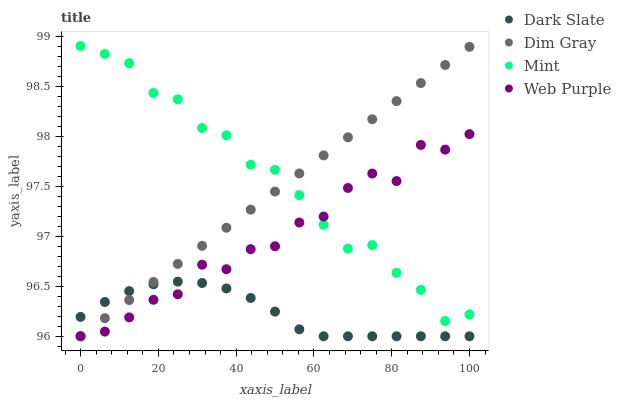Does Dark Slate have the minimum area under the curve?
Answer yes or no. Yes. Does Mint have the maximum area under the curve?
Answer yes or no. Yes. Does Web Purple have the minimum area under the curve?
Answer yes or no. No. Does Web Purple have the maximum area under the curve?
Answer yes or no. No. Is Dim Gray the smoothest?
Answer yes or no. Yes. Is Web Purple the roughest?
Answer yes or no. Yes. Is Web Purple the smoothest?
Answer yes or no. No. Is Dim Gray the roughest?
Answer yes or no. No. Does Dark Slate have the lowest value?
Answer yes or no. Yes. Does Mint have the lowest value?
Answer yes or no. No. Does Mint have the highest value?
Answer yes or no. Yes. Does Web Purple have the highest value?
Answer yes or no. No. Is Dark Slate less than Mint?
Answer yes or no. Yes. Is Mint greater than Dark Slate?
Answer yes or no. Yes. Does Dim Gray intersect Mint?
Answer yes or no. Yes. Is Dim Gray less than Mint?
Answer yes or no. No. Is Dim Gray greater than Mint?
Answer yes or no. No. Does Dark Slate intersect Mint?
Answer yes or no. No. 